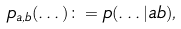Convert formula to latex. <formula><loc_0><loc_0><loc_500><loc_500>p _ { a , b } ( \dots ) \colon = p ( \dots | a b ) ,</formula> 